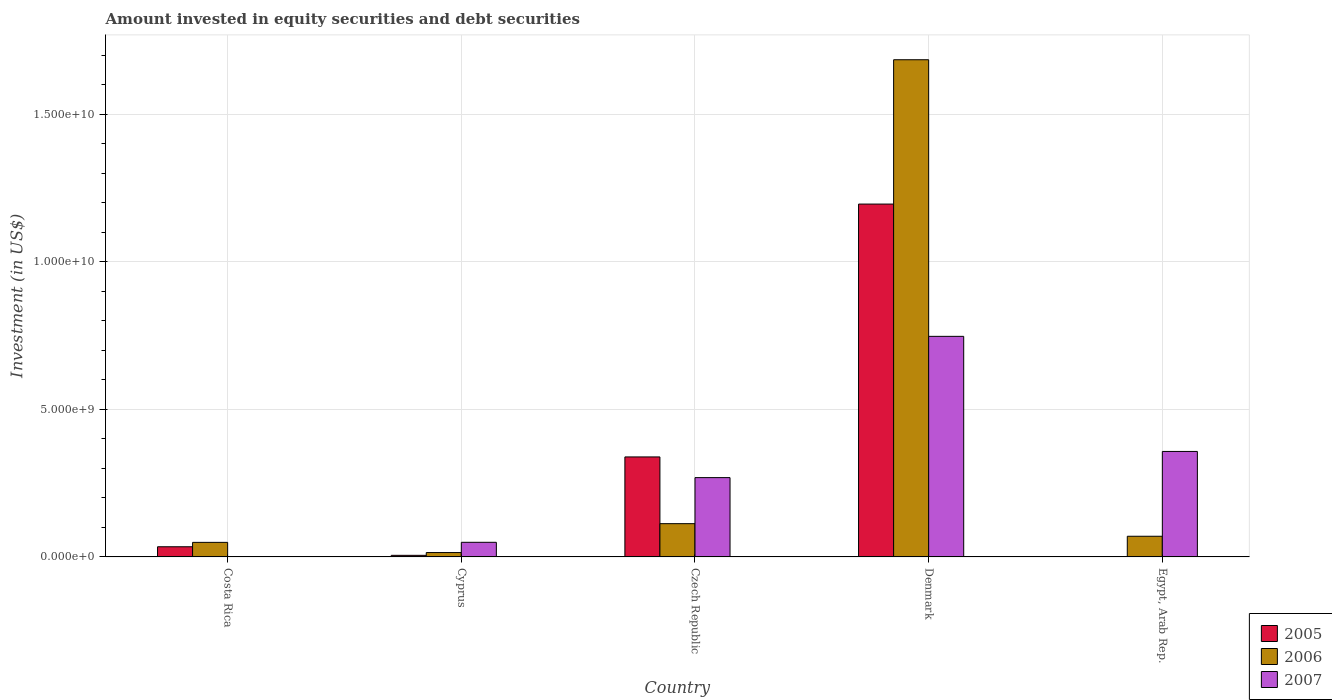How many different coloured bars are there?
Keep it short and to the point. 3. How many groups of bars are there?
Your answer should be compact. 5. How many bars are there on the 5th tick from the left?
Ensure brevity in your answer.  2. What is the label of the 5th group of bars from the left?
Your response must be concise. Egypt, Arab Rep. In how many cases, is the number of bars for a given country not equal to the number of legend labels?
Offer a terse response. 1. What is the amount invested in equity securities and debt securities in 2007 in Egypt, Arab Rep.?
Offer a terse response. 3.57e+09. Across all countries, what is the maximum amount invested in equity securities and debt securities in 2005?
Offer a very short reply. 1.20e+1. Across all countries, what is the minimum amount invested in equity securities and debt securities in 2006?
Offer a terse response. 1.48e+08. In which country was the amount invested in equity securities and debt securities in 2005 maximum?
Provide a short and direct response. Denmark. What is the total amount invested in equity securities and debt securities in 2006 in the graph?
Give a very brief answer. 1.93e+1. What is the difference between the amount invested in equity securities and debt securities in 2006 in Costa Rica and that in Egypt, Arab Rep.?
Your answer should be compact. -2.07e+08. What is the difference between the amount invested in equity securities and debt securities in 2007 in Costa Rica and the amount invested in equity securities and debt securities in 2006 in Egypt, Arab Rep.?
Make the answer very short. -7.00e+08. What is the average amount invested in equity securities and debt securities in 2007 per country?
Give a very brief answer. 2.85e+09. What is the difference between the amount invested in equity securities and debt securities of/in 2007 and amount invested in equity securities and debt securities of/in 2005 in Denmark?
Give a very brief answer. -4.48e+09. In how many countries, is the amount invested in equity securities and debt securities in 2006 greater than 15000000000 US$?
Your answer should be very brief. 1. What is the ratio of the amount invested in equity securities and debt securities in 2007 in Denmark to that in Egypt, Arab Rep.?
Give a very brief answer. 2.09. Is the amount invested in equity securities and debt securities in 2005 in Costa Rica less than that in Czech Republic?
Provide a succinct answer. Yes. What is the difference between the highest and the second highest amount invested in equity securities and debt securities in 2007?
Provide a succinct answer. 8.87e+08. What is the difference between the highest and the lowest amount invested in equity securities and debt securities in 2007?
Your response must be concise. 7.47e+09. Is the sum of the amount invested in equity securities and debt securities in 2007 in Costa Rica and Egypt, Arab Rep. greater than the maximum amount invested in equity securities and debt securities in 2005 across all countries?
Offer a terse response. No. Is it the case that in every country, the sum of the amount invested in equity securities and debt securities in 2006 and amount invested in equity securities and debt securities in 2005 is greater than the amount invested in equity securities and debt securities in 2007?
Offer a terse response. No. How many bars are there?
Your answer should be compact. 14. Are all the bars in the graph horizontal?
Offer a terse response. No. How many countries are there in the graph?
Your response must be concise. 5. What is the difference between two consecutive major ticks on the Y-axis?
Offer a very short reply. 5.00e+09. Does the graph contain any zero values?
Provide a short and direct response. Yes. How many legend labels are there?
Give a very brief answer. 3. What is the title of the graph?
Make the answer very short. Amount invested in equity securities and debt securities. What is the label or title of the Y-axis?
Provide a succinct answer. Investment (in US$). What is the Investment (in US$) of 2005 in Costa Rica?
Provide a succinct answer. 3.45e+08. What is the Investment (in US$) of 2006 in Costa Rica?
Your response must be concise. 4.93e+08. What is the Investment (in US$) in 2007 in Costa Rica?
Give a very brief answer. 3.93e+05. What is the Investment (in US$) in 2005 in Cyprus?
Your answer should be compact. 5.37e+07. What is the Investment (in US$) in 2006 in Cyprus?
Keep it short and to the point. 1.48e+08. What is the Investment (in US$) in 2007 in Cyprus?
Your answer should be very brief. 4.96e+08. What is the Investment (in US$) in 2005 in Czech Republic?
Offer a very short reply. 3.39e+09. What is the Investment (in US$) in 2006 in Czech Republic?
Offer a terse response. 1.13e+09. What is the Investment (in US$) of 2007 in Czech Republic?
Make the answer very short. 2.69e+09. What is the Investment (in US$) in 2005 in Denmark?
Give a very brief answer. 1.20e+1. What is the Investment (in US$) of 2006 in Denmark?
Make the answer very short. 1.68e+1. What is the Investment (in US$) of 2007 in Denmark?
Keep it short and to the point. 7.47e+09. What is the Investment (in US$) in 2006 in Egypt, Arab Rep.?
Provide a succinct answer. 7.00e+08. What is the Investment (in US$) in 2007 in Egypt, Arab Rep.?
Your answer should be very brief. 3.57e+09. Across all countries, what is the maximum Investment (in US$) in 2005?
Provide a short and direct response. 1.20e+1. Across all countries, what is the maximum Investment (in US$) in 2006?
Your answer should be compact. 1.68e+1. Across all countries, what is the maximum Investment (in US$) of 2007?
Provide a short and direct response. 7.47e+09. Across all countries, what is the minimum Investment (in US$) in 2006?
Offer a terse response. 1.48e+08. Across all countries, what is the minimum Investment (in US$) in 2007?
Ensure brevity in your answer.  3.93e+05. What is the total Investment (in US$) in 2005 in the graph?
Ensure brevity in your answer.  1.57e+1. What is the total Investment (in US$) in 2006 in the graph?
Give a very brief answer. 1.93e+1. What is the total Investment (in US$) in 2007 in the graph?
Your response must be concise. 1.42e+1. What is the difference between the Investment (in US$) in 2005 in Costa Rica and that in Cyprus?
Keep it short and to the point. 2.91e+08. What is the difference between the Investment (in US$) in 2006 in Costa Rica and that in Cyprus?
Make the answer very short. 3.45e+08. What is the difference between the Investment (in US$) of 2007 in Costa Rica and that in Cyprus?
Your response must be concise. -4.95e+08. What is the difference between the Investment (in US$) in 2005 in Costa Rica and that in Czech Republic?
Offer a terse response. -3.04e+09. What is the difference between the Investment (in US$) in 2006 in Costa Rica and that in Czech Republic?
Your response must be concise. -6.34e+08. What is the difference between the Investment (in US$) in 2007 in Costa Rica and that in Czech Republic?
Keep it short and to the point. -2.69e+09. What is the difference between the Investment (in US$) in 2005 in Costa Rica and that in Denmark?
Your response must be concise. -1.16e+1. What is the difference between the Investment (in US$) of 2006 in Costa Rica and that in Denmark?
Provide a short and direct response. -1.64e+1. What is the difference between the Investment (in US$) in 2007 in Costa Rica and that in Denmark?
Provide a short and direct response. -7.47e+09. What is the difference between the Investment (in US$) in 2006 in Costa Rica and that in Egypt, Arab Rep.?
Make the answer very short. -2.07e+08. What is the difference between the Investment (in US$) in 2007 in Costa Rica and that in Egypt, Arab Rep.?
Keep it short and to the point. -3.57e+09. What is the difference between the Investment (in US$) in 2005 in Cyprus and that in Czech Republic?
Give a very brief answer. -3.33e+09. What is the difference between the Investment (in US$) of 2006 in Cyprus and that in Czech Republic?
Make the answer very short. -9.79e+08. What is the difference between the Investment (in US$) of 2007 in Cyprus and that in Czech Republic?
Keep it short and to the point. -2.19e+09. What is the difference between the Investment (in US$) in 2005 in Cyprus and that in Denmark?
Your answer should be very brief. -1.19e+1. What is the difference between the Investment (in US$) in 2006 in Cyprus and that in Denmark?
Offer a terse response. -1.67e+1. What is the difference between the Investment (in US$) of 2007 in Cyprus and that in Denmark?
Ensure brevity in your answer.  -6.98e+09. What is the difference between the Investment (in US$) of 2006 in Cyprus and that in Egypt, Arab Rep.?
Make the answer very short. -5.52e+08. What is the difference between the Investment (in US$) in 2007 in Cyprus and that in Egypt, Arab Rep.?
Your response must be concise. -3.08e+09. What is the difference between the Investment (in US$) of 2005 in Czech Republic and that in Denmark?
Your answer should be very brief. -8.57e+09. What is the difference between the Investment (in US$) of 2006 in Czech Republic and that in Denmark?
Make the answer very short. -1.57e+1. What is the difference between the Investment (in US$) of 2007 in Czech Republic and that in Denmark?
Provide a short and direct response. -4.79e+09. What is the difference between the Investment (in US$) in 2006 in Czech Republic and that in Egypt, Arab Rep.?
Your answer should be very brief. 4.27e+08. What is the difference between the Investment (in US$) in 2007 in Czech Republic and that in Egypt, Arab Rep.?
Provide a short and direct response. -8.87e+08. What is the difference between the Investment (in US$) in 2006 in Denmark and that in Egypt, Arab Rep.?
Your response must be concise. 1.61e+1. What is the difference between the Investment (in US$) of 2007 in Denmark and that in Egypt, Arab Rep.?
Provide a short and direct response. 3.90e+09. What is the difference between the Investment (in US$) of 2005 in Costa Rica and the Investment (in US$) of 2006 in Cyprus?
Give a very brief answer. 1.96e+08. What is the difference between the Investment (in US$) of 2005 in Costa Rica and the Investment (in US$) of 2007 in Cyprus?
Give a very brief answer. -1.51e+08. What is the difference between the Investment (in US$) of 2006 in Costa Rica and the Investment (in US$) of 2007 in Cyprus?
Your response must be concise. -2.46e+06. What is the difference between the Investment (in US$) of 2005 in Costa Rica and the Investment (in US$) of 2006 in Czech Republic?
Your answer should be very brief. -7.83e+08. What is the difference between the Investment (in US$) in 2005 in Costa Rica and the Investment (in US$) in 2007 in Czech Republic?
Keep it short and to the point. -2.34e+09. What is the difference between the Investment (in US$) in 2006 in Costa Rica and the Investment (in US$) in 2007 in Czech Republic?
Keep it short and to the point. -2.19e+09. What is the difference between the Investment (in US$) of 2005 in Costa Rica and the Investment (in US$) of 2006 in Denmark?
Your answer should be compact. -1.65e+1. What is the difference between the Investment (in US$) of 2005 in Costa Rica and the Investment (in US$) of 2007 in Denmark?
Give a very brief answer. -7.13e+09. What is the difference between the Investment (in US$) in 2006 in Costa Rica and the Investment (in US$) in 2007 in Denmark?
Your answer should be compact. -6.98e+09. What is the difference between the Investment (in US$) in 2005 in Costa Rica and the Investment (in US$) in 2006 in Egypt, Arab Rep.?
Ensure brevity in your answer.  -3.56e+08. What is the difference between the Investment (in US$) of 2005 in Costa Rica and the Investment (in US$) of 2007 in Egypt, Arab Rep.?
Your answer should be very brief. -3.23e+09. What is the difference between the Investment (in US$) in 2006 in Costa Rica and the Investment (in US$) in 2007 in Egypt, Arab Rep.?
Provide a succinct answer. -3.08e+09. What is the difference between the Investment (in US$) in 2005 in Cyprus and the Investment (in US$) in 2006 in Czech Republic?
Keep it short and to the point. -1.07e+09. What is the difference between the Investment (in US$) of 2005 in Cyprus and the Investment (in US$) of 2007 in Czech Republic?
Your response must be concise. -2.63e+09. What is the difference between the Investment (in US$) in 2006 in Cyprus and the Investment (in US$) in 2007 in Czech Republic?
Make the answer very short. -2.54e+09. What is the difference between the Investment (in US$) in 2005 in Cyprus and the Investment (in US$) in 2006 in Denmark?
Ensure brevity in your answer.  -1.68e+1. What is the difference between the Investment (in US$) of 2005 in Cyprus and the Investment (in US$) of 2007 in Denmark?
Keep it short and to the point. -7.42e+09. What is the difference between the Investment (in US$) of 2006 in Cyprus and the Investment (in US$) of 2007 in Denmark?
Keep it short and to the point. -7.33e+09. What is the difference between the Investment (in US$) in 2005 in Cyprus and the Investment (in US$) in 2006 in Egypt, Arab Rep.?
Give a very brief answer. -6.47e+08. What is the difference between the Investment (in US$) in 2005 in Cyprus and the Investment (in US$) in 2007 in Egypt, Arab Rep.?
Provide a short and direct response. -3.52e+09. What is the difference between the Investment (in US$) of 2006 in Cyprus and the Investment (in US$) of 2007 in Egypt, Arab Rep.?
Offer a terse response. -3.43e+09. What is the difference between the Investment (in US$) of 2005 in Czech Republic and the Investment (in US$) of 2006 in Denmark?
Give a very brief answer. -1.35e+1. What is the difference between the Investment (in US$) of 2005 in Czech Republic and the Investment (in US$) of 2007 in Denmark?
Ensure brevity in your answer.  -4.09e+09. What is the difference between the Investment (in US$) in 2006 in Czech Republic and the Investment (in US$) in 2007 in Denmark?
Your answer should be compact. -6.35e+09. What is the difference between the Investment (in US$) of 2005 in Czech Republic and the Investment (in US$) of 2006 in Egypt, Arab Rep.?
Offer a terse response. 2.69e+09. What is the difference between the Investment (in US$) of 2005 in Czech Republic and the Investment (in US$) of 2007 in Egypt, Arab Rep.?
Keep it short and to the point. -1.86e+08. What is the difference between the Investment (in US$) in 2006 in Czech Republic and the Investment (in US$) in 2007 in Egypt, Arab Rep.?
Keep it short and to the point. -2.45e+09. What is the difference between the Investment (in US$) of 2005 in Denmark and the Investment (in US$) of 2006 in Egypt, Arab Rep.?
Offer a terse response. 1.13e+1. What is the difference between the Investment (in US$) of 2005 in Denmark and the Investment (in US$) of 2007 in Egypt, Arab Rep.?
Provide a short and direct response. 8.38e+09. What is the difference between the Investment (in US$) in 2006 in Denmark and the Investment (in US$) in 2007 in Egypt, Arab Rep.?
Provide a short and direct response. 1.33e+1. What is the average Investment (in US$) in 2005 per country?
Your response must be concise. 3.15e+09. What is the average Investment (in US$) of 2006 per country?
Make the answer very short. 3.86e+09. What is the average Investment (in US$) in 2007 per country?
Offer a terse response. 2.85e+09. What is the difference between the Investment (in US$) of 2005 and Investment (in US$) of 2006 in Costa Rica?
Ensure brevity in your answer.  -1.49e+08. What is the difference between the Investment (in US$) in 2005 and Investment (in US$) in 2007 in Costa Rica?
Your answer should be very brief. 3.44e+08. What is the difference between the Investment (in US$) of 2006 and Investment (in US$) of 2007 in Costa Rica?
Make the answer very short. 4.93e+08. What is the difference between the Investment (in US$) in 2005 and Investment (in US$) in 2006 in Cyprus?
Ensure brevity in your answer.  -9.46e+07. What is the difference between the Investment (in US$) of 2005 and Investment (in US$) of 2007 in Cyprus?
Offer a very short reply. -4.42e+08. What is the difference between the Investment (in US$) of 2006 and Investment (in US$) of 2007 in Cyprus?
Your answer should be compact. -3.47e+08. What is the difference between the Investment (in US$) in 2005 and Investment (in US$) in 2006 in Czech Republic?
Make the answer very short. 2.26e+09. What is the difference between the Investment (in US$) in 2005 and Investment (in US$) in 2007 in Czech Republic?
Make the answer very short. 7.01e+08. What is the difference between the Investment (in US$) of 2006 and Investment (in US$) of 2007 in Czech Republic?
Make the answer very short. -1.56e+09. What is the difference between the Investment (in US$) in 2005 and Investment (in US$) in 2006 in Denmark?
Ensure brevity in your answer.  -4.89e+09. What is the difference between the Investment (in US$) in 2005 and Investment (in US$) in 2007 in Denmark?
Keep it short and to the point. 4.48e+09. What is the difference between the Investment (in US$) in 2006 and Investment (in US$) in 2007 in Denmark?
Your answer should be very brief. 9.37e+09. What is the difference between the Investment (in US$) of 2006 and Investment (in US$) of 2007 in Egypt, Arab Rep.?
Your response must be concise. -2.87e+09. What is the ratio of the Investment (in US$) in 2005 in Costa Rica to that in Cyprus?
Ensure brevity in your answer.  6.41. What is the ratio of the Investment (in US$) in 2006 in Costa Rica to that in Cyprus?
Offer a very short reply. 3.32. What is the ratio of the Investment (in US$) of 2007 in Costa Rica to that in Cyprus?
Offer a terse response. 0. What is the ratio of the Investment (in US$) in 2005 in Costa Rica to that in Czech Republic?
Offer a very short reply. 0.1. What is the ratio of the Investment (in US$) in 2006 in Costa Rica to that in Czech Republic?
Keep it short and to the point. 0.44. What is the ratio of the Investment (in US$) in 2007 in Costa Rica to that in Czech Republic?
Make the answer very short. 0. What is the ratio of the Investment (in US$) of 2005 in Costa Rica to that in Denmark?
Keep it short and to the point. 0.03. What is the ratio of the Investment (in US$) of 2006 in Costa Rica to that in Denmark?
Give a very brief answer. 0.03. What is the ratio of the Investment (in US$) of 2006 in Costa Rica to that in Egypt, Arab Rep.?
Keep it short and to the point. 0.7. What is the ratio of the Investment (in US$) in 2005 in Cyprus to that in Czech Republic?
Offer a very short reply. 0.02. What is the ratio of the Investment (in US$) of 2006 in Cyprus to that in Czech Republic?
Your response must be concise. 0.13. What is the ratio of the Investment (in US$) of 2007 in Cyprus to that in Czech Republic?
Provide a short and direct response. 0.18. What is the ratio of the Investment (in US$) of 2005 in Cyprus to that in Denmark?
Provide a short and direct response. 0. What is the ratio of the Investment (in US$) in 2006 in Cyprus to that in Denmark?
Make the answer very short. 0.01. What is the ratio of the Investment (in US$) of 2007 in Cyprus to that in Denmark?
Offer a terse response. 0.07. What is the ratio of the Investment (in US$) of 2006 in Cyprus to that in Egypt, Arab Rep.?
Your response must be concise. 0.21. What is the ratio of the Investment (in US$) in 2007 in Cyprus to that in Egypt, Arab Rep.?
Ensure brevity in your answer.  0.14. What is the ratio of the Investment (in US$) of 2005 in Czech Republic to that in Denmark?
Offer a very short reply. 0.28. What is the ratio of the Investment (in US$) of 2006 in Czech Republic to that in Denmark?
Ensure brevity in your answer.  0.07. What is the ratio of the Investment (in US$) in 2007 in Czech Republic to that in Denmark?
Keep it short and to the point. 0.36. What is the ratio of the Investment (in US$) in 2006 in Czech Republic to that in Egypt, Arab Rep.?
Your answer should be very brief. 1.61. What is the ratio of the Investment (in US$) of 2007 in Czech Republic to that in Egypt, Arab Rep.?
Your answer should be very brief. 0.75. What is the ratio of the Investment (in US$) of 2006 in Denmark to that in Egypt, Arab Rep.?
Provide a succinct answer. 24.05. What is the ratio of the Investment (in US$) of 2007 in Denmark to that in Egypt, Arab Rep.?
Provide a succinct answer. 2.09. What is the difference between the highest and the second highest Investment (in US$) of 2005?
Provide a short and direct response. 8.57e+09. What is the difference between the highest and the second highest Investment (in US$) of 2006?
Keep it short and to the point. 1.57e+1. What is the difference between the highest and the second highest Investment (in US$) in 2007?
Your answer should be very brief. 3.90e+09. What is the difference between the highest and the lowest Investment (in US$) in 2005?
Your answer should be compact. 1.20e+1. What is the difference between the highest and the lowest Investment (in US$) in 2006?
Offer a very short reply. 1.67e+1. What is the difference between the highest and the lowest Investment (in US$) in 2007?
Offer a very short reply. 7.47e+09. 